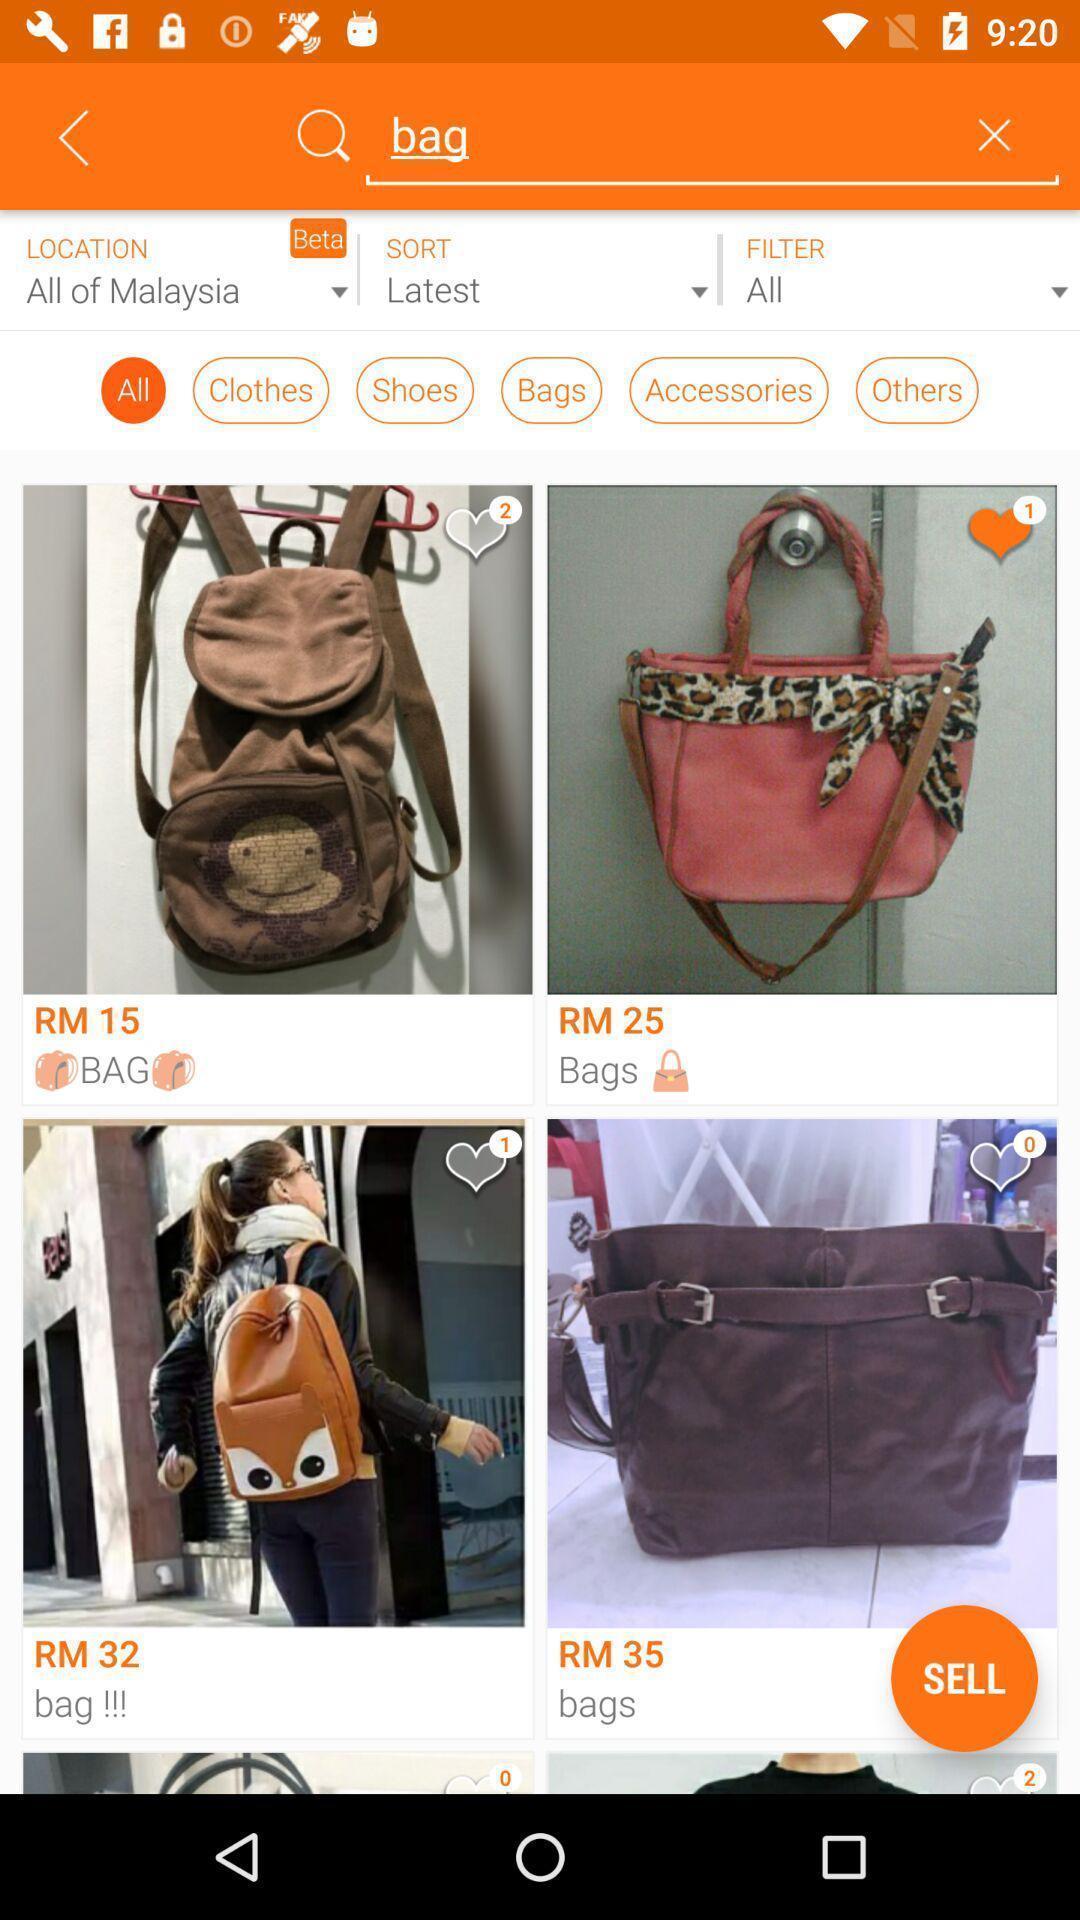What details can you identify in this image? Various bags in a shopping app. 